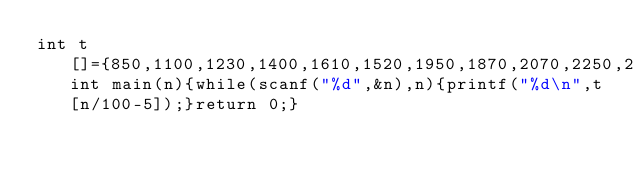Convert code to text. <code><loc_0><loc_0><loc_500><loc_500><_C_>int t[]={850,1100,1230,1400,1610,1520,1950,1870,2070,2250,2244,2620,2624,2794,3004,3040,3344,3390,3590,3740,3764,4120,4114,4314,4494,4488,4864,4868,5038,5248,5284,5588,5634,5834,5984,6008,6364,6358,6558,6738,6732,7108,7112,7282,7492,7528};int main(n){while(scanf("%d",&n),n){printf("%d\n",t[n/100-5]);}return 0;}</code> 